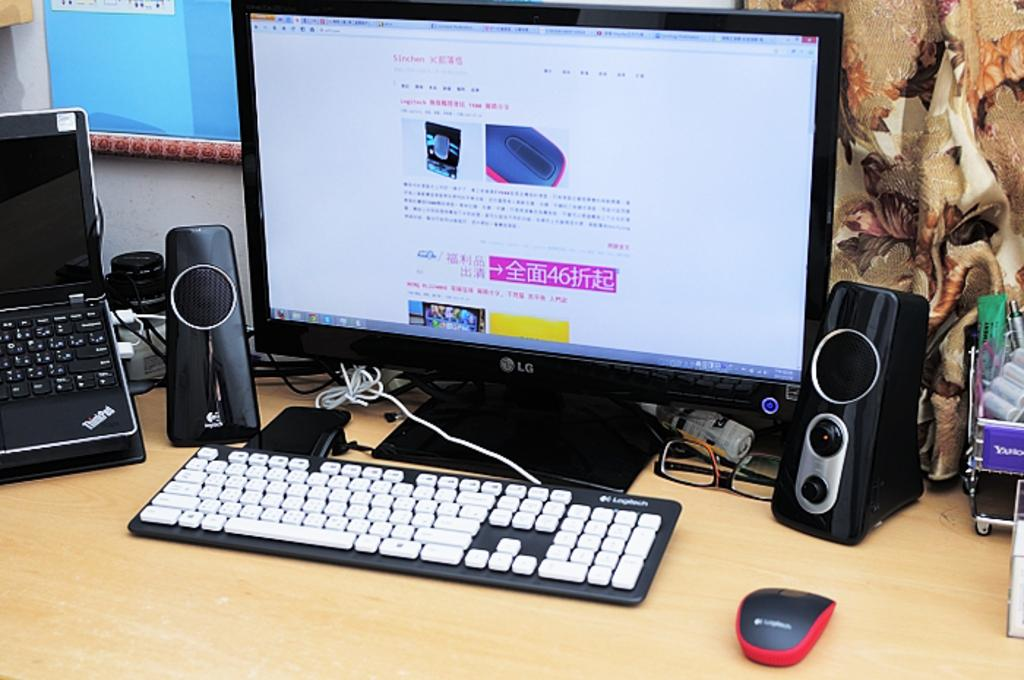<image>
Present a compact description of the photo's key features. A Thinkpad laptop sits on a wooden desk next to an LG monitor. 